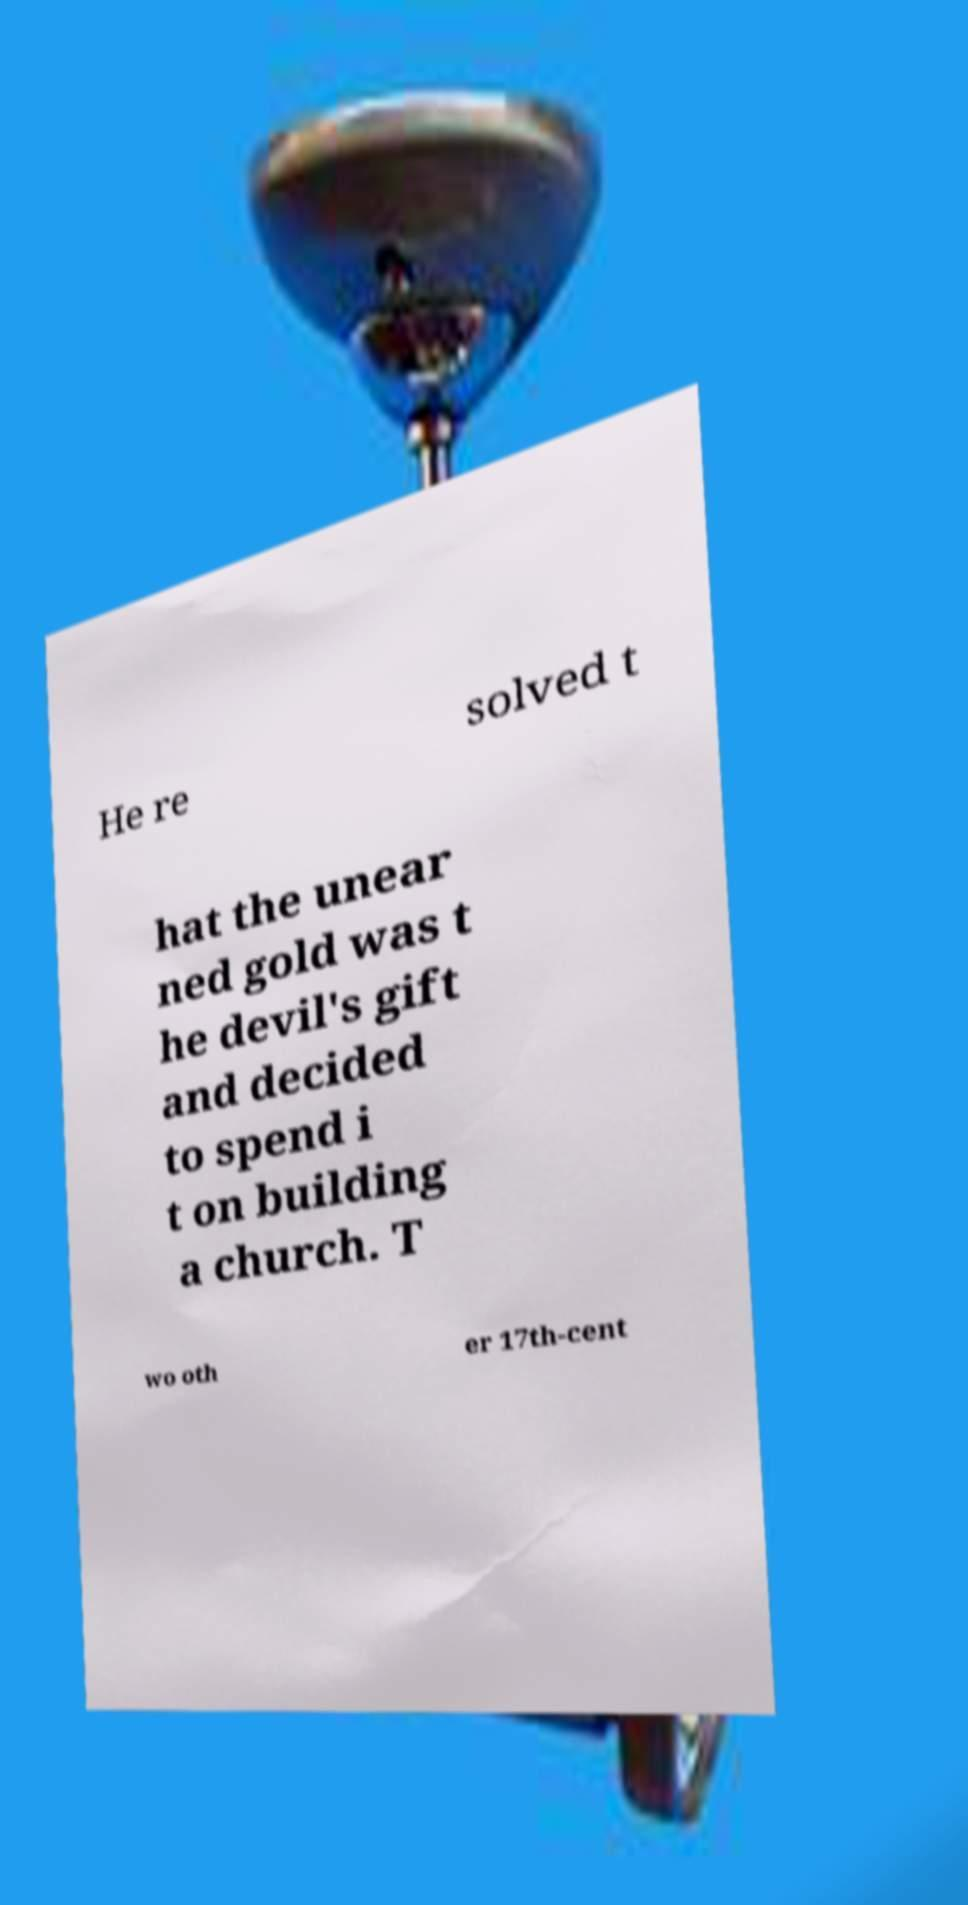I need the written content from this picture converted into text. Can you do that? He re solved t hat the unear ned gold was t he devil's gift and decided to spend i t on building a church. T wo oth er 17th-cent 